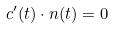<formula> <loc_0><loc_0><loc_500><loc_500>c ^ { \prime } ( t ) \cdot n ( t ) = 0</formula> 